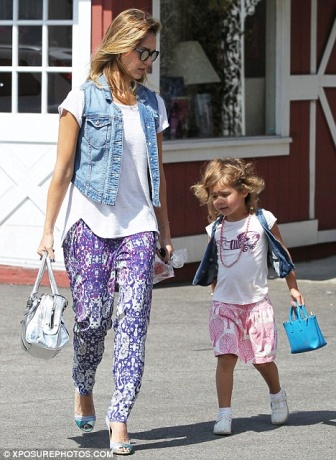Can you tell me more about where they might be going? Given their relaxed demeanor and the mother's shopping bags, they could be on their way home after a pleasant shopping spree. The mother’s confident stride and the daughter's happy expression suggest a fulfilling outing, perhaps they enjoyed a visit to a local market or a favorite boutique. What kind of relationship do you think they have? The image appears to depict a close and affectionate relationship between the mother and daughter. Their matching accessories and coordinated outfits hint at a shared sense of style and camaraderie. The way the daughter walks closely behind her mother suggests trust and admiration, while the mother's stride signifies confidence and care. 